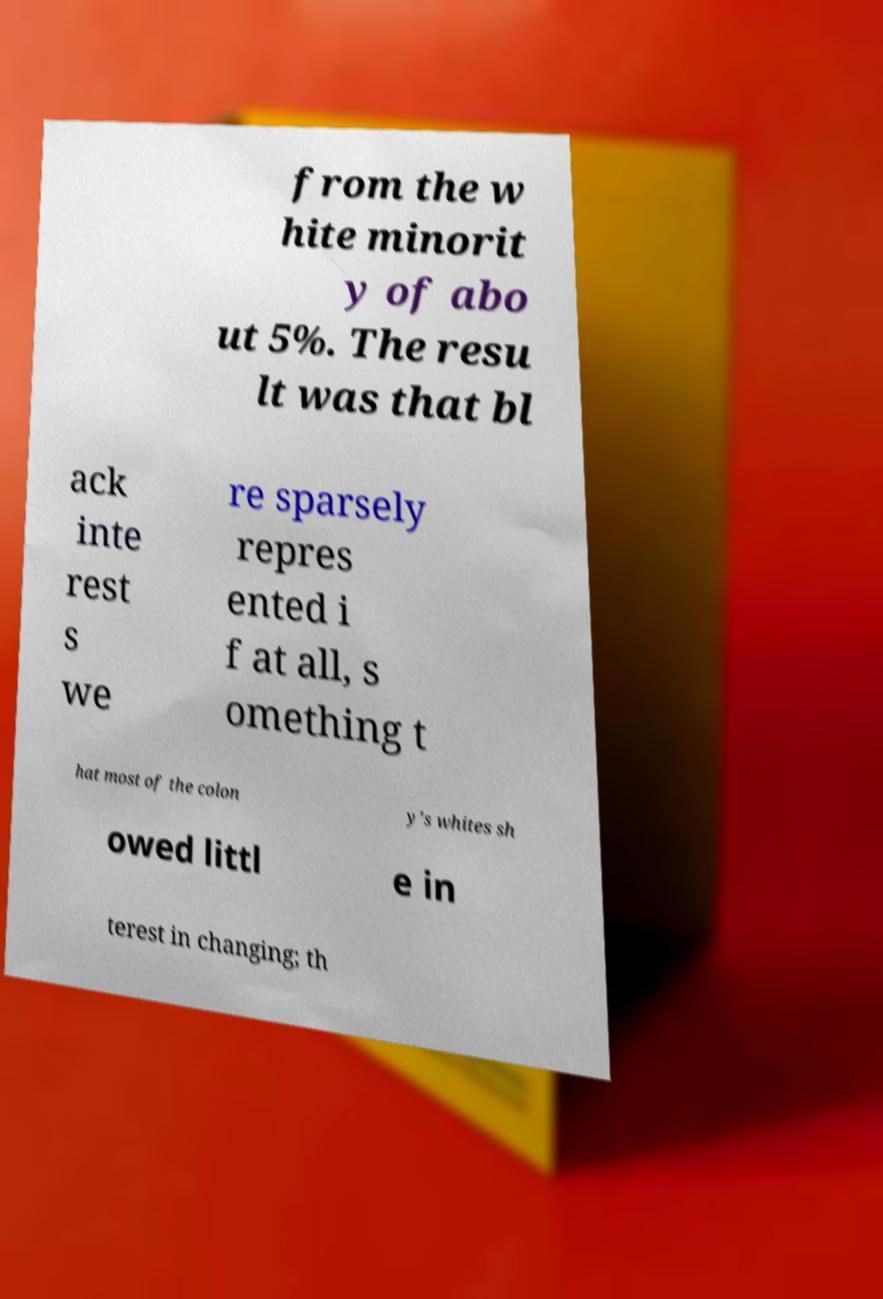Please identify and transcribe the text found in this image. from the w hite minorit y of abo ut 5%. The resu lt was that bl ack inte rest s we re sparsely repres ented i f at all, s omething t hat most of the colon y's whites sh owed littl e in terest in changing; th 